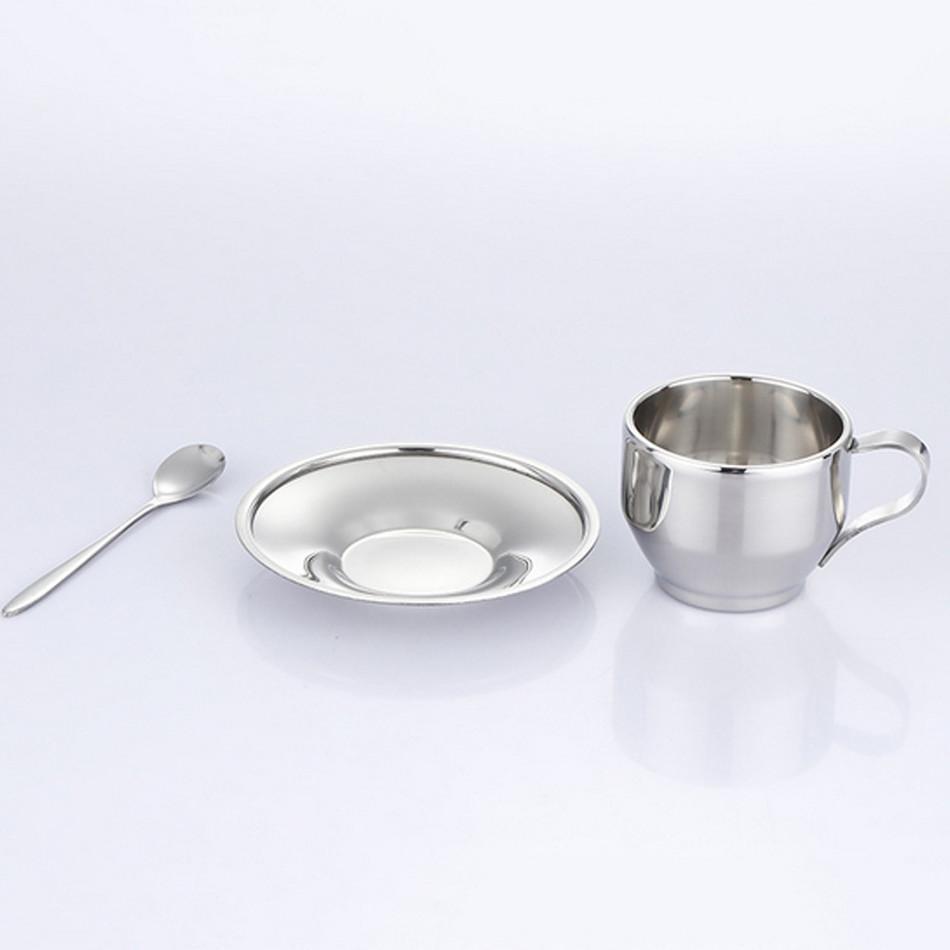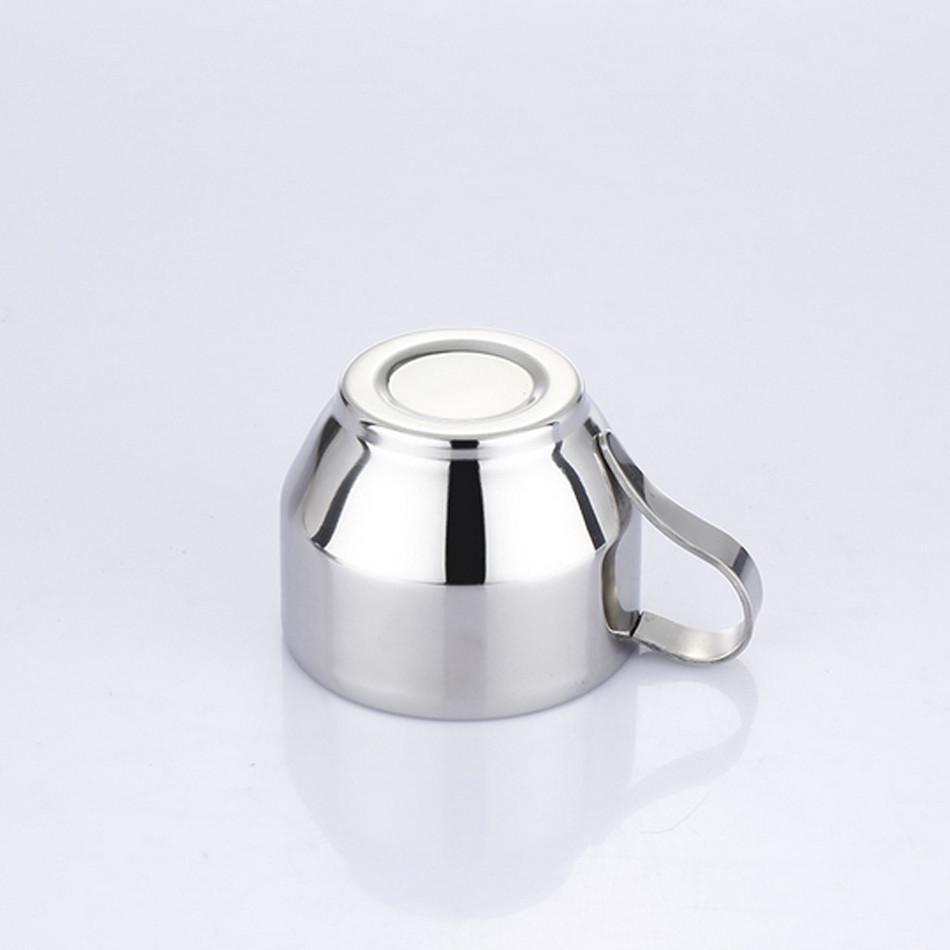The first image is the image on the left, the second image is the image on the right. For the images shown, is this caption "The spoon is in the cup in the image on the right." true? Answer yes or no. No. 